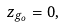<formula> <loc_0><loc_0><loc_500><loc_500>z _ { g _ { o } } = 0 ,</formula> 